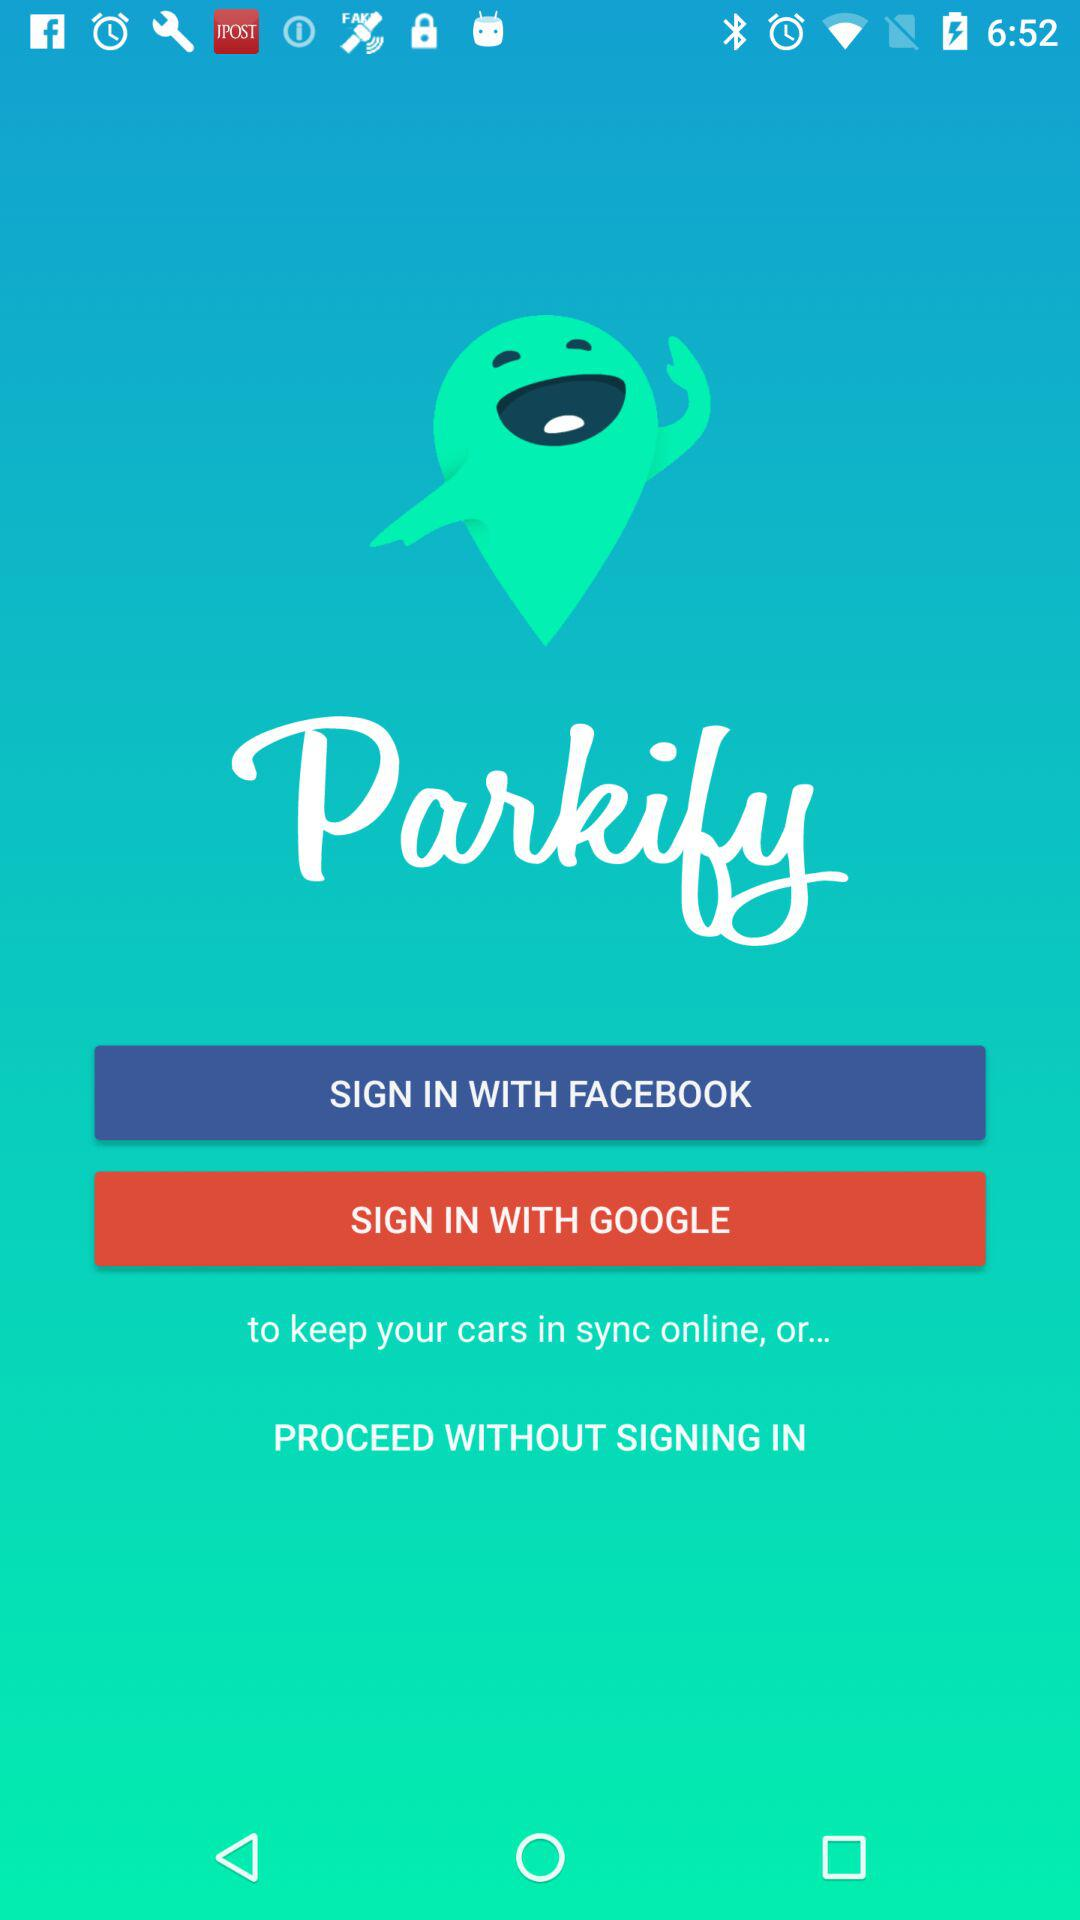How long does it take to sign in with "GOOGLE"?
When the provided information is insufficient, respond with <no answer>. <no answer> 